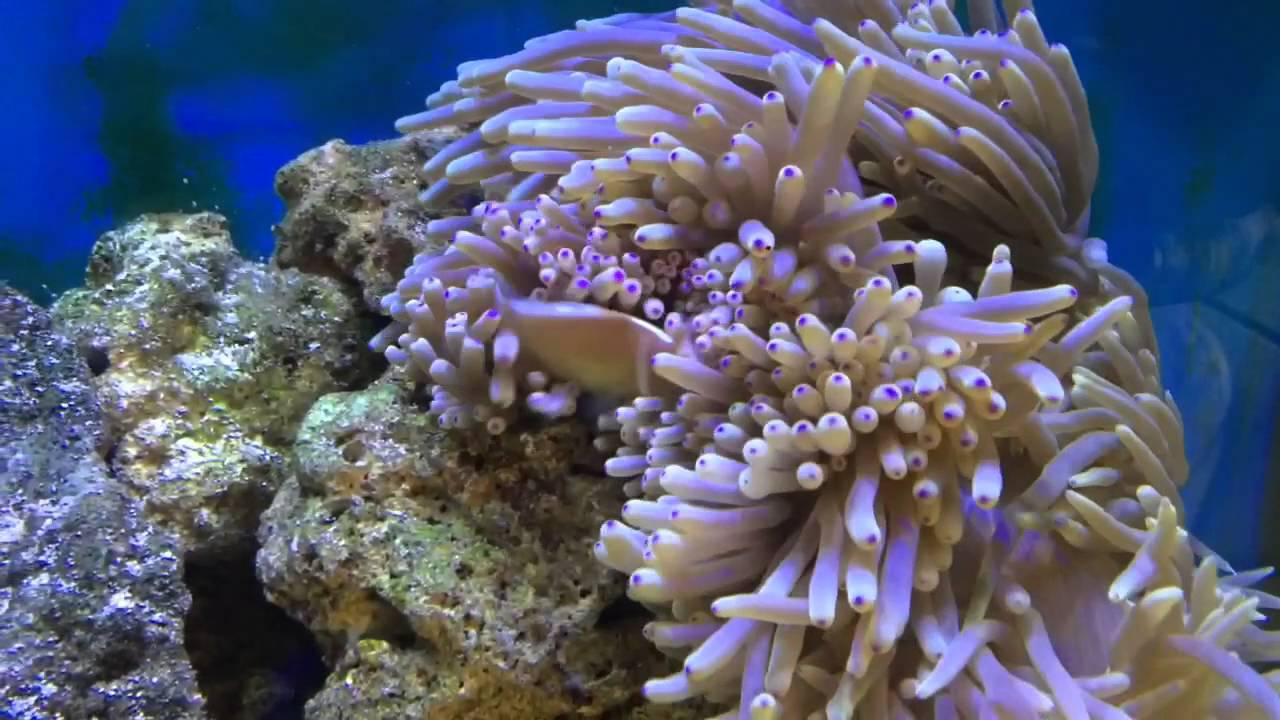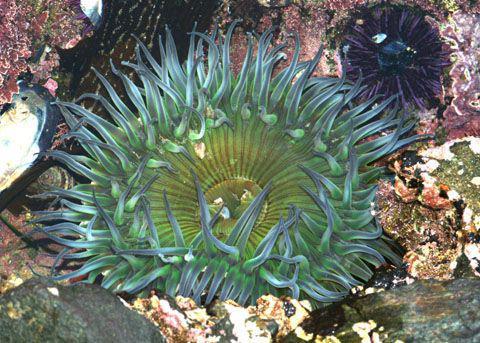The first image is the image on the left, the second image is the image on the right. For the images displayed, is the sentence "One image shows a single prominent clownfish with head and body facing left, in front of neutral-colored anemone tendrils." factually correct? Answer yes or no. No. The first image is the image on the left, the second image is the image on the right. Considering the images on both sides, is "At least 2 clown fish are swimming near a large sea urchin." valid? Answer yes or no. No. 